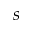<formula> <loc_0><loc_0><loc_500><loc_500>s</formula> 